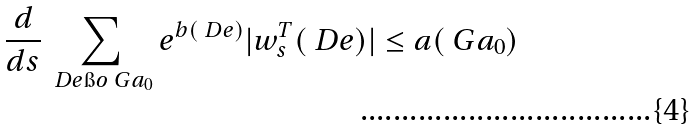Convert formula to latex. <formula><loc_0><loc_0><loc_500><loc_500>\frac { d } { d s } \sum _ { \ D e \i o \ G a _ { 0 } } e ^ { b ( \ D e ) } | w ^ { T } _ { s } ( \ D e ) | \leq a ( \ G a _ { 0 } )</formula> 